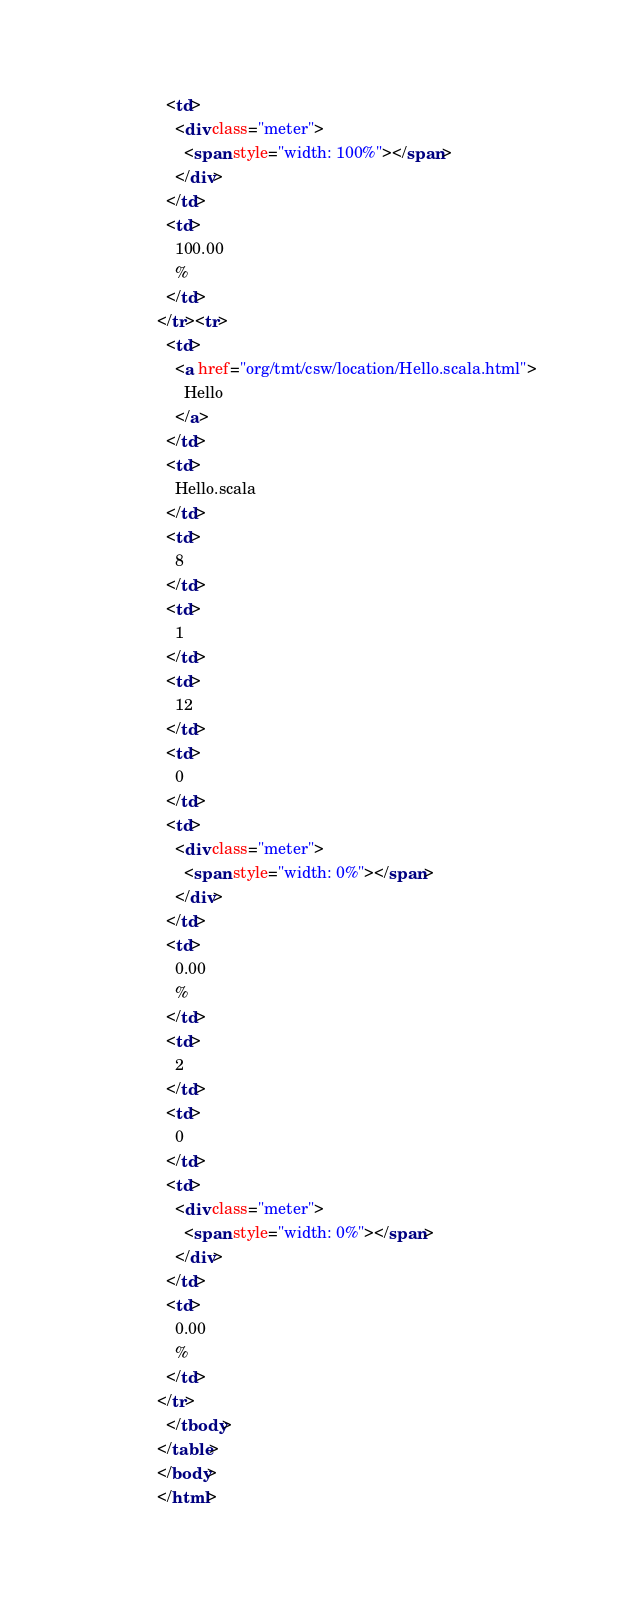Convert code to text. <code><loc_0><loc_0><loc_500><loc_500><_HTML_>      <td>
        <div class="meter">
          <span style="width: 100%"></span>
        </div>
      </td>
      <td>
        100.00
        %
      </td>
    </tr><tr>
      <td>
        <a href="org/tmt/csw/location/Hello.scala.html">
          Hello
        </a>
      </td>
      <td>
        Hello.scala
      </td>
      <td>
        8
      </td>
      <td>
        1
      </td>
      <td>
        12
      </td>
      <td>
        0
      </td>
      <td>
        <div class="meter">
          <span style="width: 0%"></span>
        </div>
      </td>
      <td>
        0.00
        %
      </td>
      <td>
        2
      </td>
      <td>
        0
      </td>
      <td>
        <div class="meter">
          <span style="width: 0%"></span>
        </div>
      </td>
      <td>
        0.00
        %
      </td>
    </tr>
      </tbody>
    </table>
    </body>
    </html></code> 